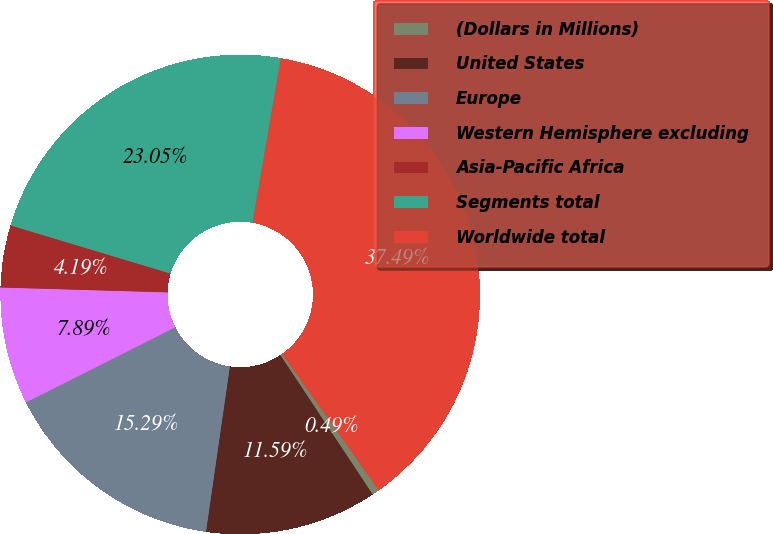Convert chart. <chart><loc_0><loc_0><loc_500><loc_500><pie_chart><fcel>(Dollars in Millions)<fcel>United States<fcel>Europe<fcel>Western Hemisphere excluding<fcel>Asia-Pacific Africa<fcel>Segments total<fcel>Worldwide total<nl><fcel>0.49%<fcel>11.59%<fcel>15.29%<fcel>7.89%<fcel>4.19%<fcel>23.05%<fcel>37.49%<nl></chart> 